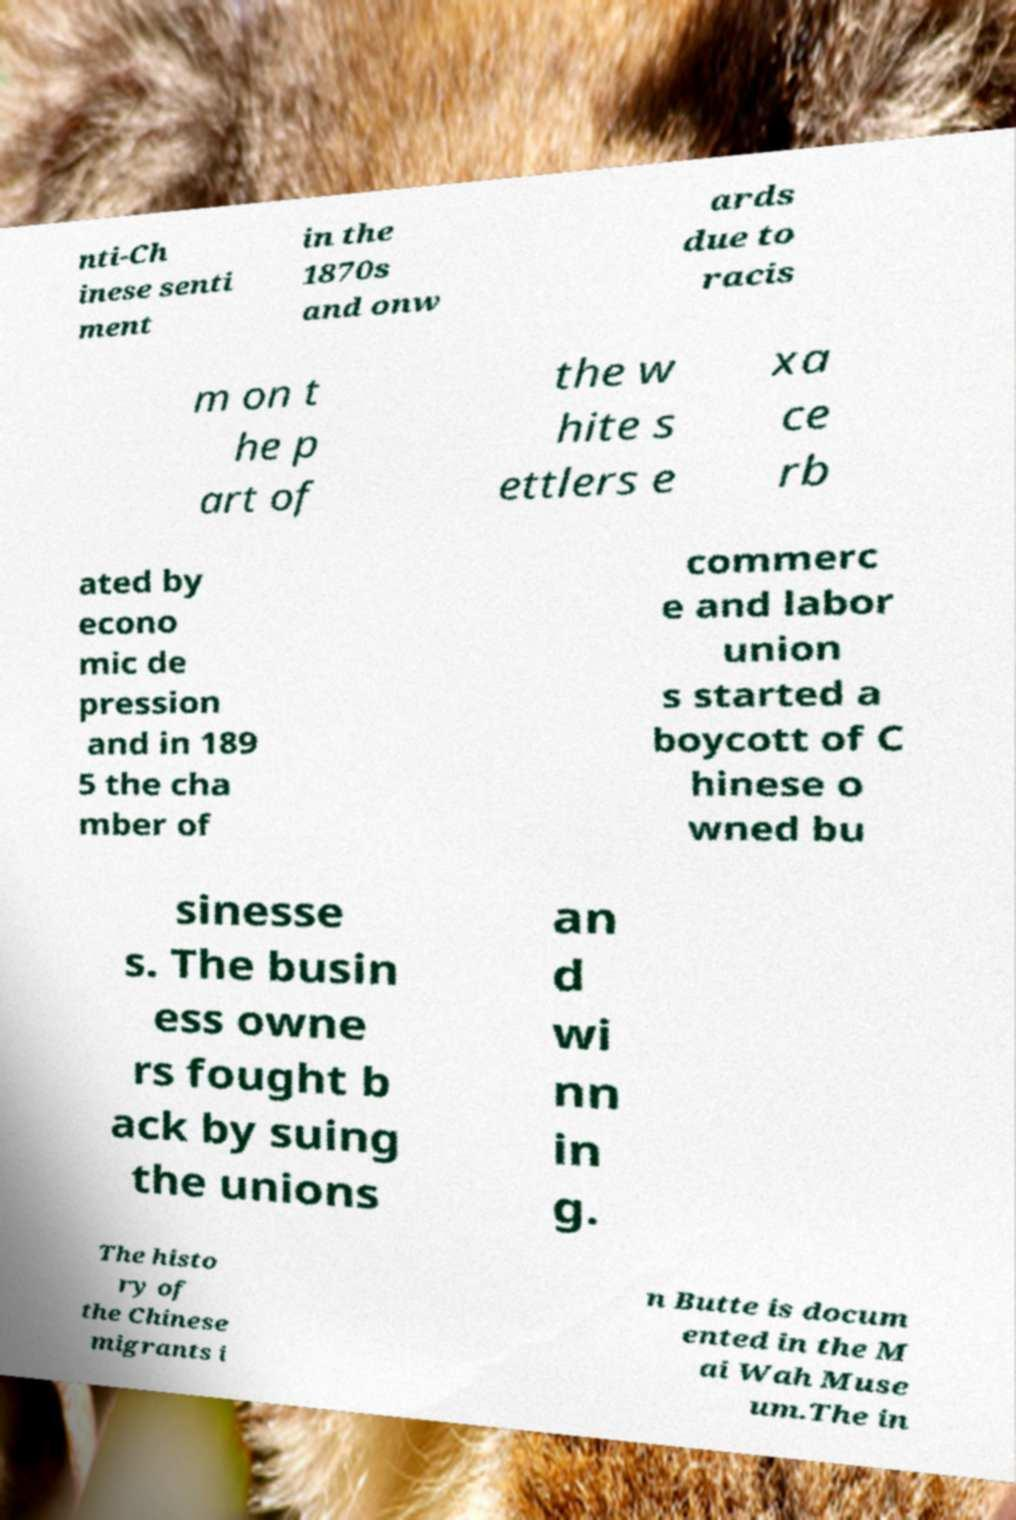Please identify and transcribe the text found in this image. nti-Ch inese senti ment in the 1870s and onw ards due to racis m on t he p art of the w hite s ettlers e xa ce rb ated by econo mic de pression and in 189 5 the cha mber of commerc e and labor union s started a boycott of C hinese o wned bu sinesse s. The busin ess owne rs fought b ack by suing the unions an d wi nn in g. The histo ry of the Chinese migrants i n Butte is docum ented in the M ai Wah Muse um.The in 